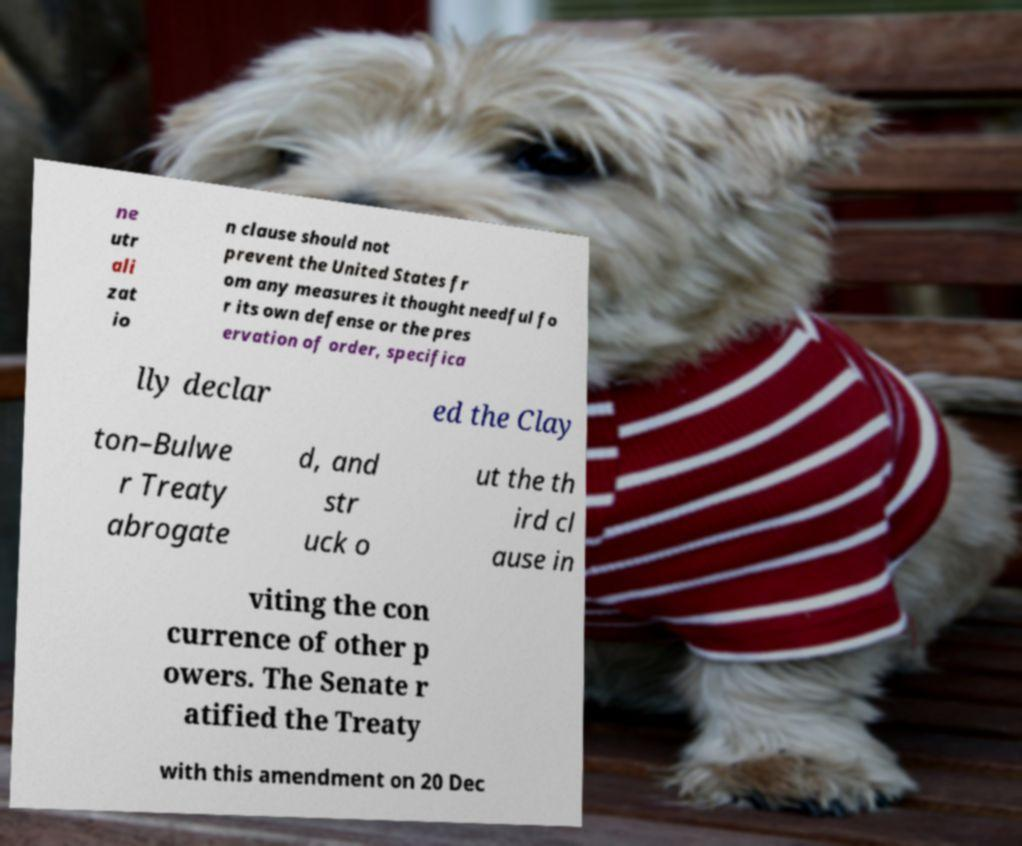Could you extract and type out the text from this image? ne utr ali zat io n clause should not prevent the United States fr om any measures it thought needful fo r its own defense or the pres ervation of order, specifica lly declar ed the Clay ton–Bulwe r Treaty abrogate d, and str uck o ut the th ird cl ause in viting the con currence of other p owers. The Senate r atified the Treaty with this amendment on 20 Dec 